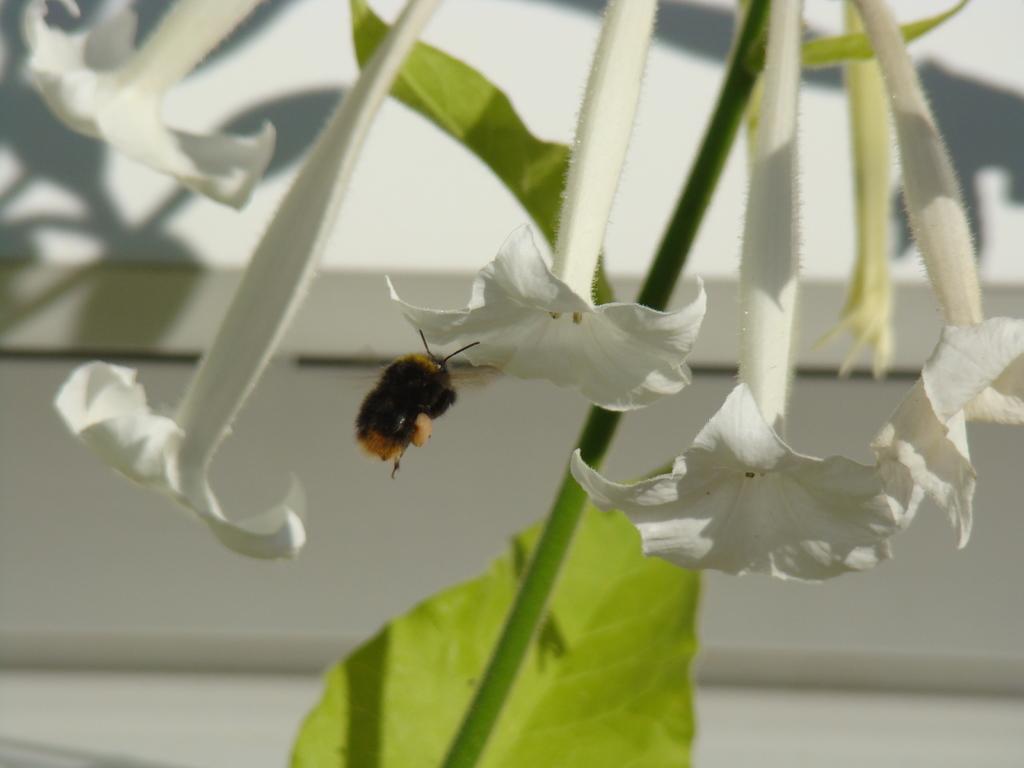Could you give a brief overview of what you see in this image? In the image we can see there is a bee sitting on the flower and there are white colour flowers on the plants. Background of the image is little blurred. 